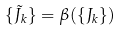Convert formula to latex. <formula><loc_0><loc_0><loc_500><loc_500>\{ \tilde { J } _ { k } \} = \beta ( \{ J _ { k } \} )</formula> 